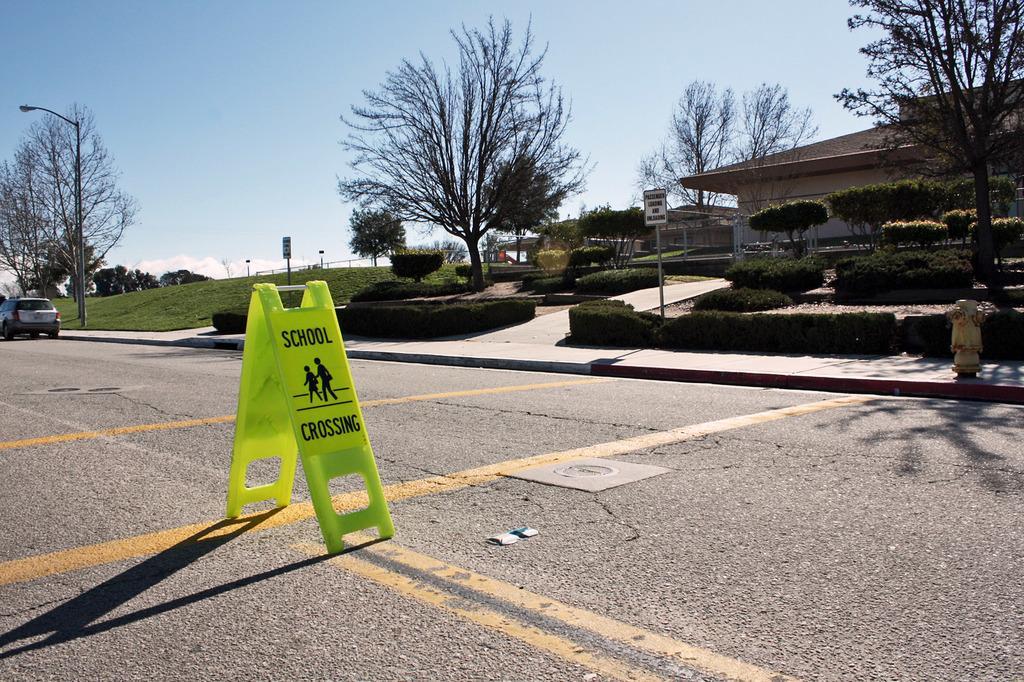How would you summarize this image in a sentence or two? There is a sign board and a car on the left side of the image, there are plants, houses, trees, poles and sky in the background area. There is a water pump on the right side. 